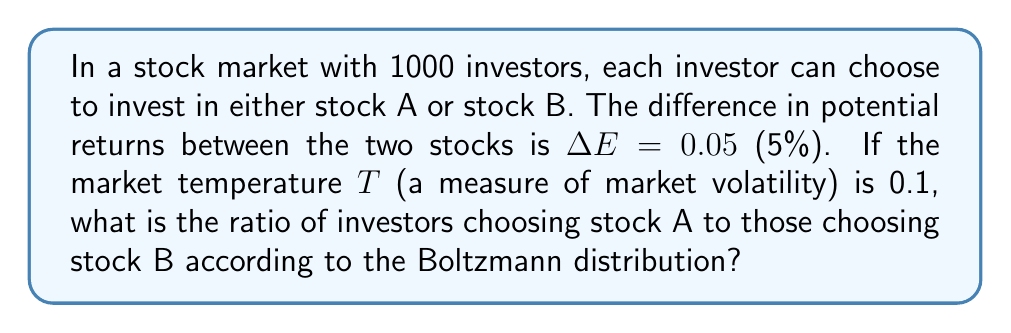Teach me how to tackle this problem. To solve this problem, we'll use the Boltzmann distribution to model investor behavior. The steps are as follows:

1) The Boltzmann distribution gives the probability of a system being in a state with energy $E_i$ as:

   $$P_i \propto e^{-E_i/kT}$$

   where $k$ is Boltzmann's constant (in this case, we can assume $k=1$ for simplicity).

2) In our case, we have two states: stock A and stock B. Let's assume stock A has the higher potential return, so the energy difference $\Delta E = E_B - E_A = 0.05$.

3) The ratio of probabilities (which in this case represents the ratio of investors) is given by:

   $$\frac{P_A}{P_B} = \frac{e^{-E_A/T}}{e^{-E_B/T}} = e^{(E_B-E_A)/T} = e^{\Delta E/T}$$

4) Substituting the given values:

   $$\frac{P_A}{P_B} = e^{0.05/0.1} = e^{0.5}$$

5) Calculate this value:

   $$e^{0.5} \approx 1.6487$$

Therefore, the ratio of investors choosing stock A to those choosing stock B is approximately 1.6487 to 1.
Answer: 1.6487 : 1 